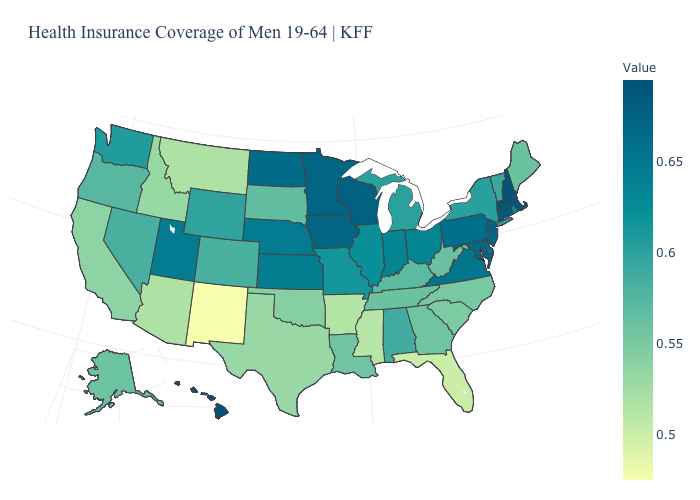Which states hav the highest value in the MidWest?
Keep it brief. Wisconsin. Does New Mexico have the lowest value in the West?
Be succinct. Yes. Does New Mexico have the lowest value in the West?
Write a very short answer. Yes. Does Colorado have a lower value than Maine?
Be succinct. No. Among the states that border California , which have the lowest value?
Short answer required. Arizona. 